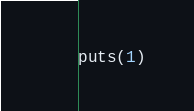<code> <loc_0><loc_0><loc_500><loc_500><_Ruby_>puts(1)</code> 